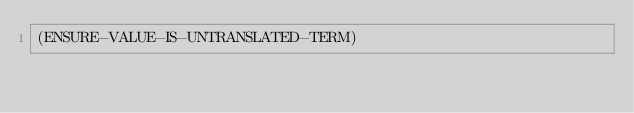<code> <loc_0><loc_0><loc_500><loc_500><_Lisp_>(ENSURE-VALUE-IS-UNTRANSLATED-TERM)
</code> 